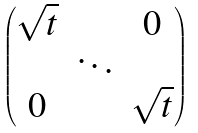Convert formula to latex. <formula><loc_0><loc_0><loc_500><loc_500>\begin{pmatrix} \sqrt { t } & & 0 \\ & \ddots & \\ 0 & & \sqrt { t } \end{pmatrix}</formula> 